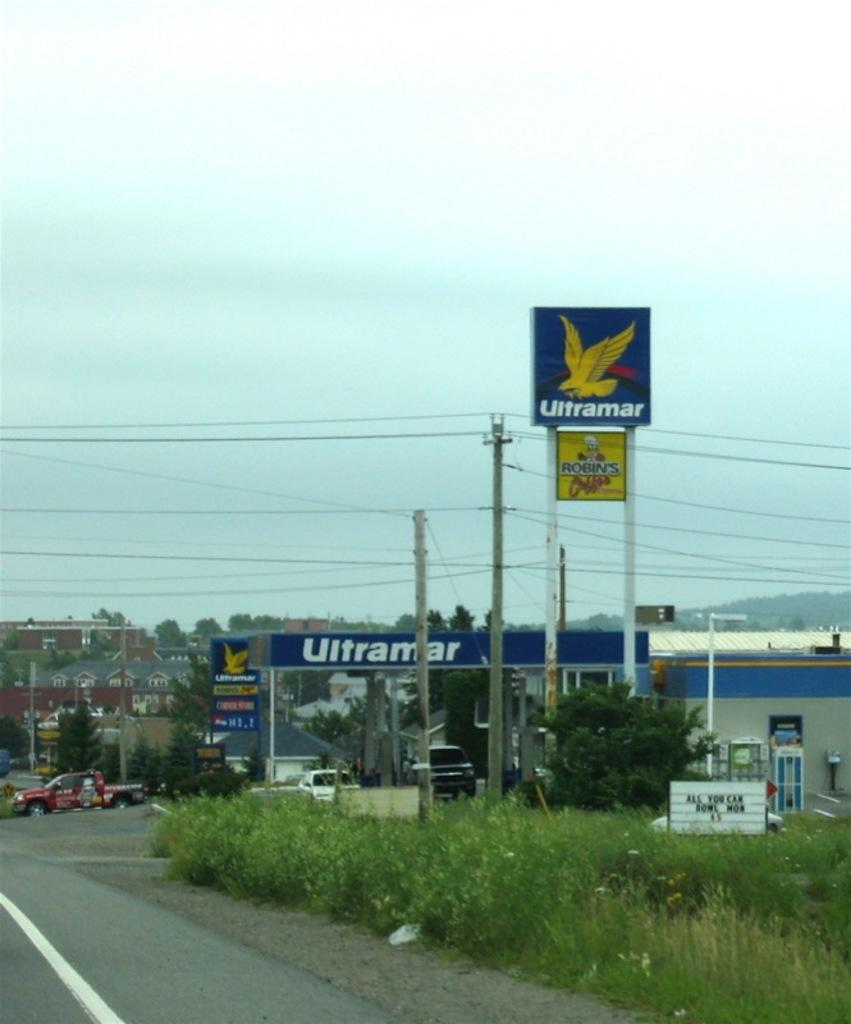<image>
Write a terse but informative summary of the picture. An Ultramar gas station is situated on the side of the road. 